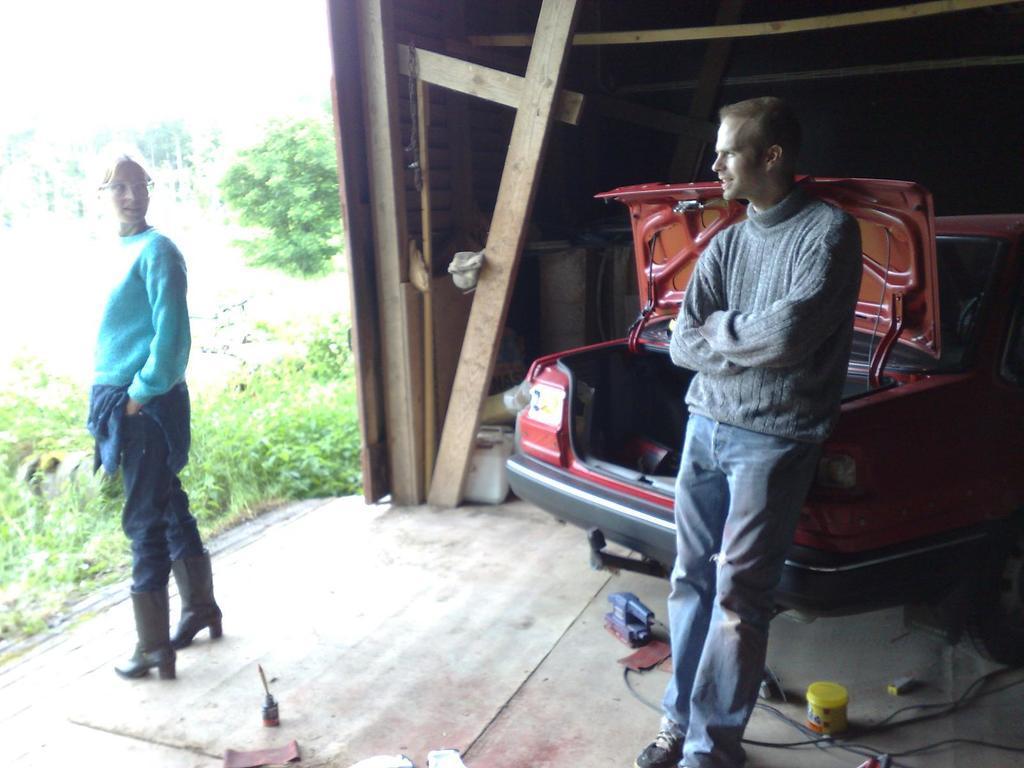Can you describe this image briefly? In this image we can see two persons standing and we can also see vehicle, wooden objects, trees and plants. 